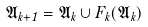<formula> <loc_0><loc_0><loc_500><loc_500>\mathfrak { A } _ { k + 1 } = \mathfrak { A } _ { k } \cup F _ { k } ( \mathfrak { A } _ { k } )</formula> 